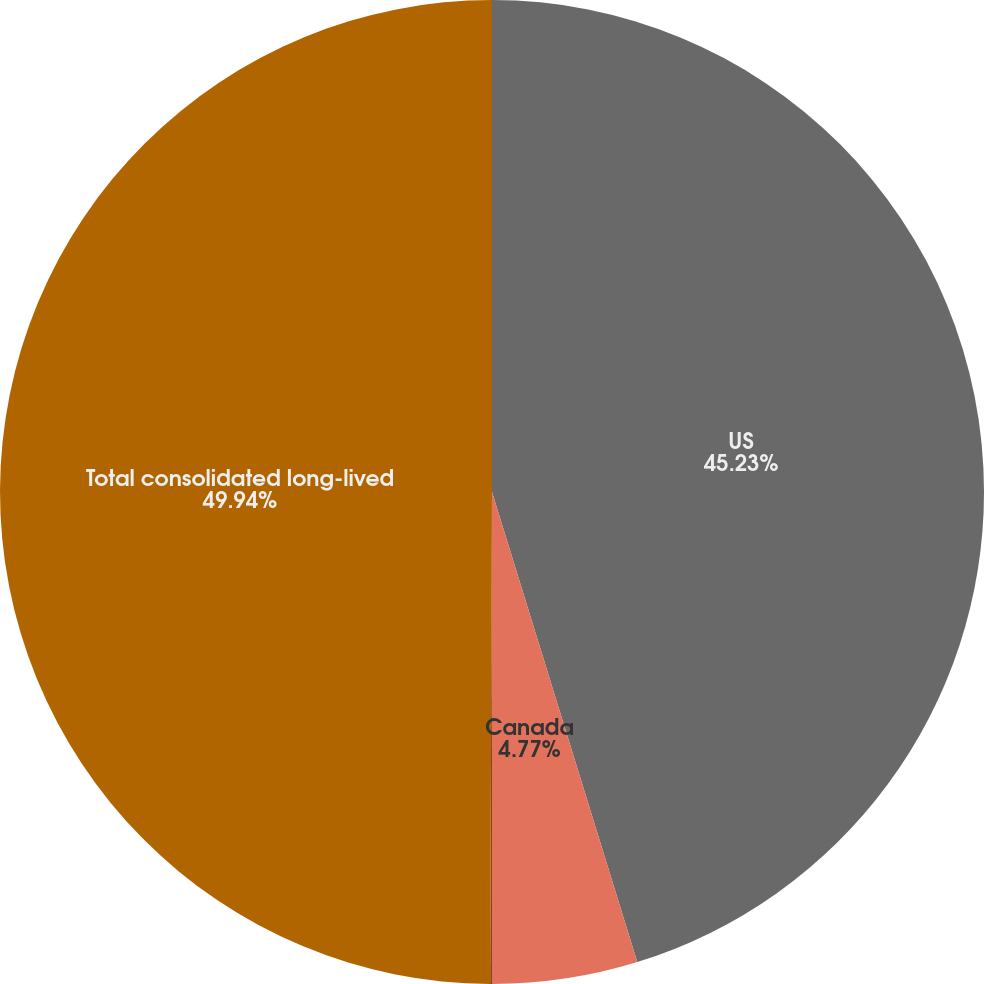<chart> <loc_0><loc_0><loc_500><loc_500><pie_chart><fcel>US<fcel>Canada<fcel>Mexico<fcel>Total consolidated long-lived<nl><fcel>45.23%<fcel>4.77%<fcel>0.06%<fcel>49.94%<nl></chart> 